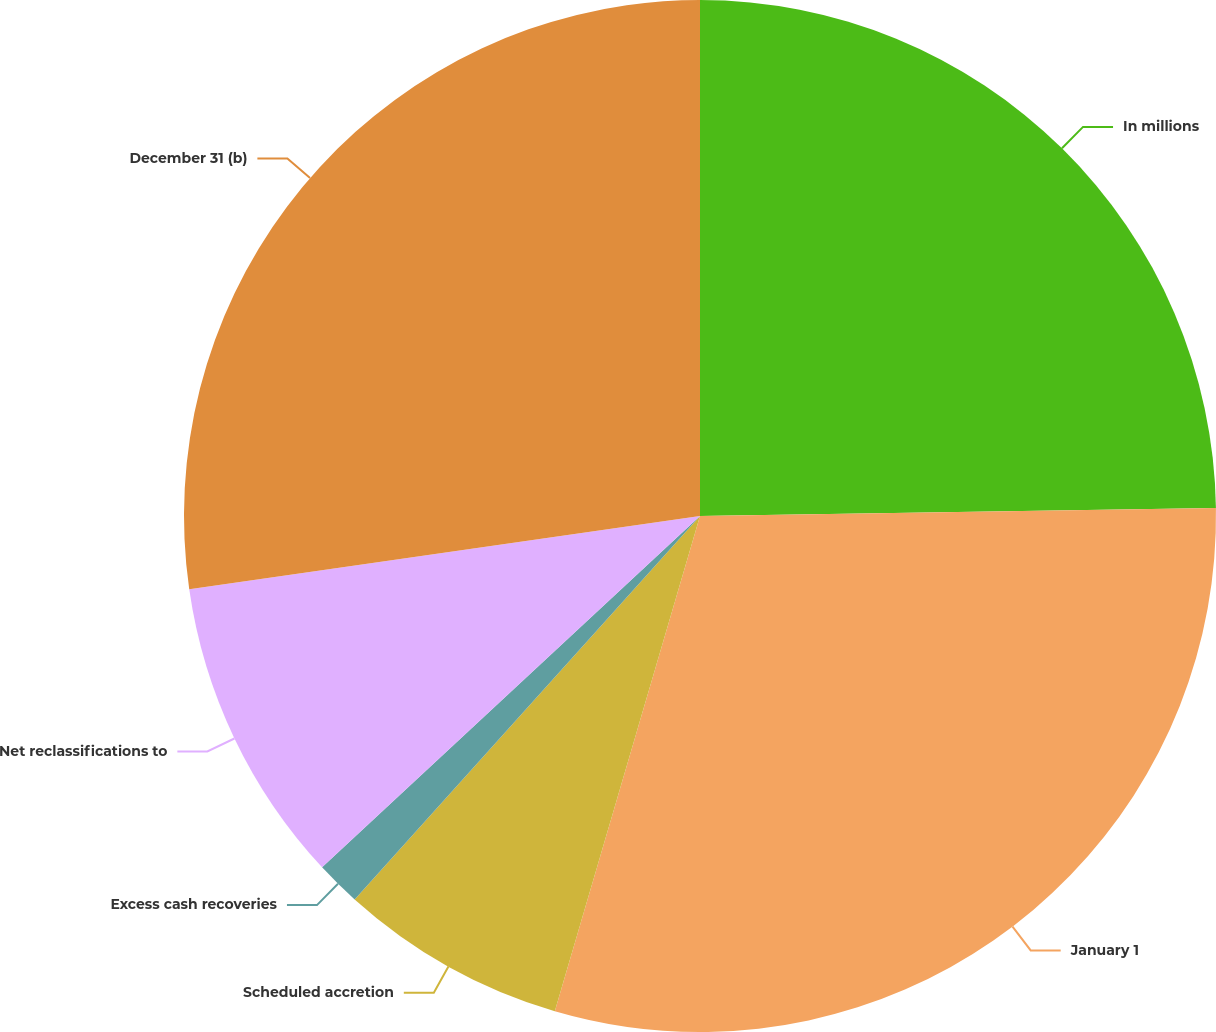<chart> <loc_0><loc_0><loc_500><loc_500><pie_chart><fcel>In millions<fcel>January 1<fcel>Scheduled accretion<fcel>Excess cash recoveries<fcel>Net reclassifications to<fcel>December 31 (b)<nl><fcel>24.75%<fcel>29.79%<fcel>7.13%<fcel>1.41%<fcel>9.65%<fcel>27.27%<nl></chart> 